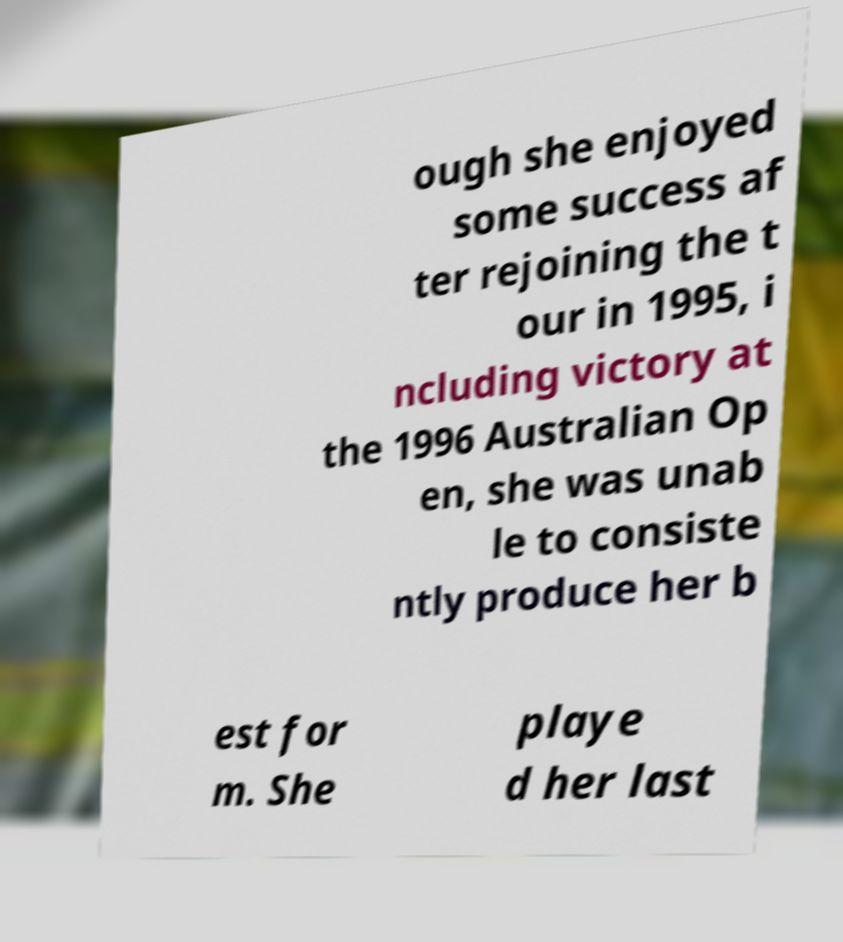I need the written content from this picture converted into text. Can you do that? ough she enjoyed some success af ter rejoining the t our in 1995, i ncluding victory at the 1996 Australian Op en, she was unab le to consiste ntly produce her b est for m. She playe d her last 